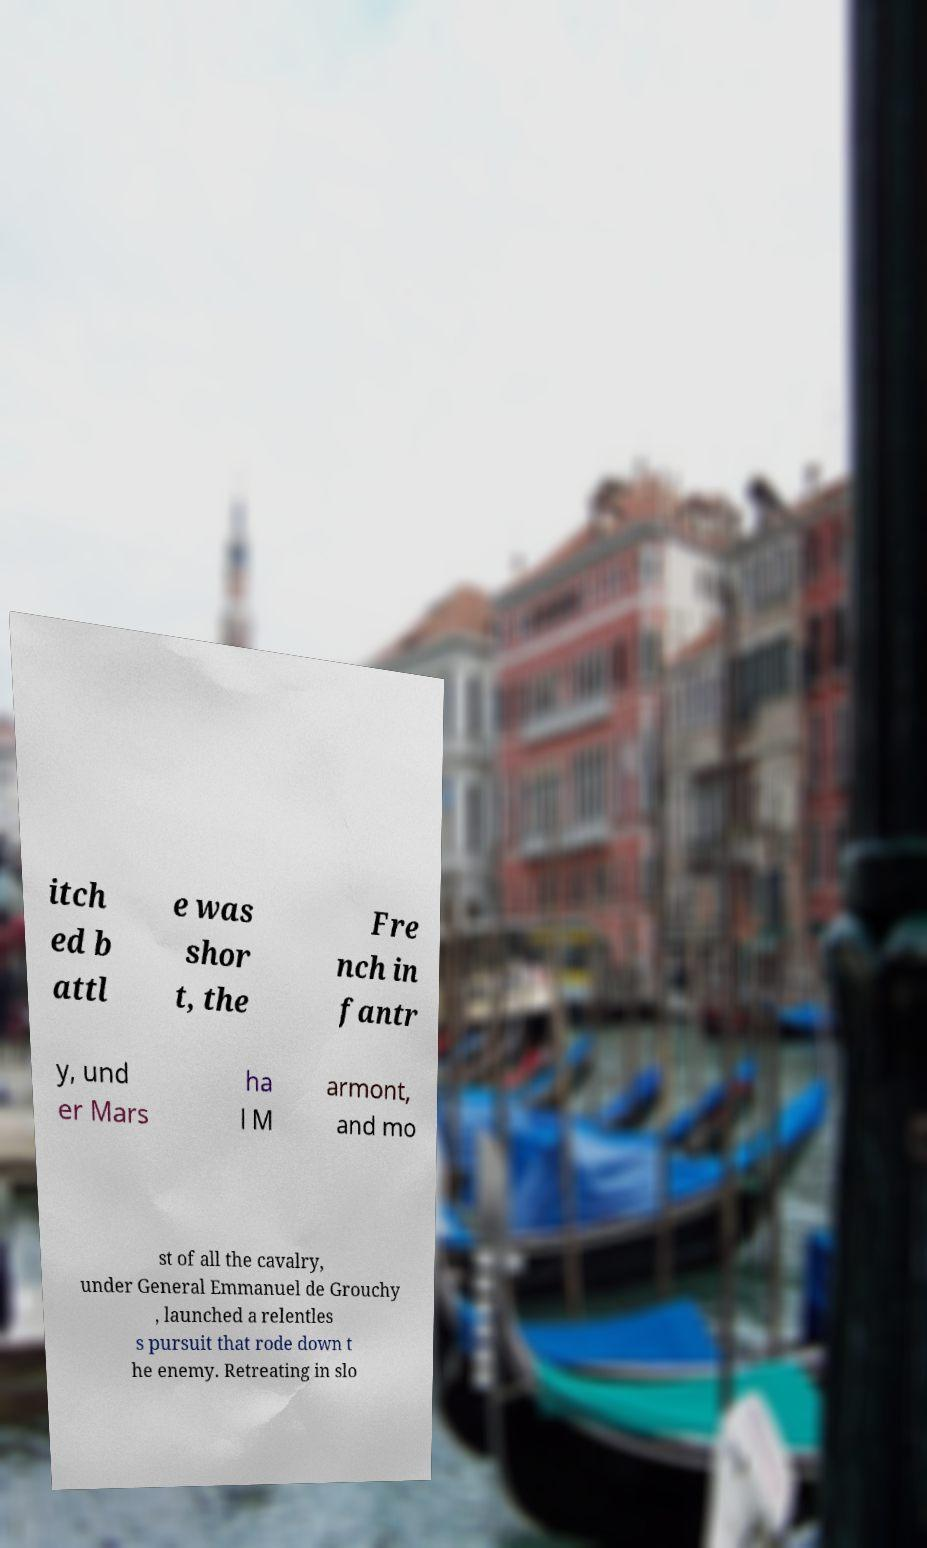I need the written content from this picture converted into text. Can you do that? itch ed b attl e was shor t, the Fre nch in fantr y, und er Mars ha l M armont, and mo st of all the cavalry, under General Emmanuel de Grouchy , launched a relentles s pursuit that rode down t he enemy. Retreating in slo 